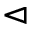<formula> <loc_0><loc_0><loc_500><loc_500>\vartriangleleft</formula> 